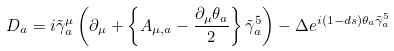<formula> <loc_0><loc_0><loc_500><loc_500>D _ { a } = i \tilde { \gamma } ^ { \mu } _ { a } \left ( \partial _ { \mu } + \left \{ A _ { \mu , a } - \frac { \partial _ { \mu } \theta _ { a } } { 2 } \right \} \tilde { \gamma } ^ { 5 } _ { a } \right ) - \Delta e ^ { i ( 1 - d s ) \theta _ { a } \tilde { \gamma } ^ { 5 } _ { a } }</formula> 